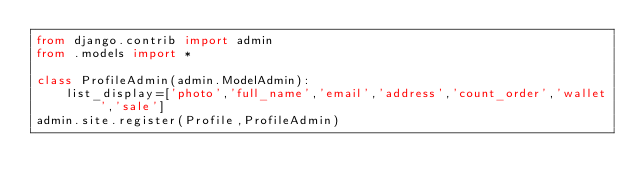<code> <loc_0><loc_0><loc_500><loc_500><_Python_>from django.contrib import admin
from .models import *

class ProfileAdmin(admin.ModelAdmin):
    list_display=['photo','full_name','email','address','count_order','wallet','sale']
admin.site.register(Profile,ProfileAdmin)
</code> 